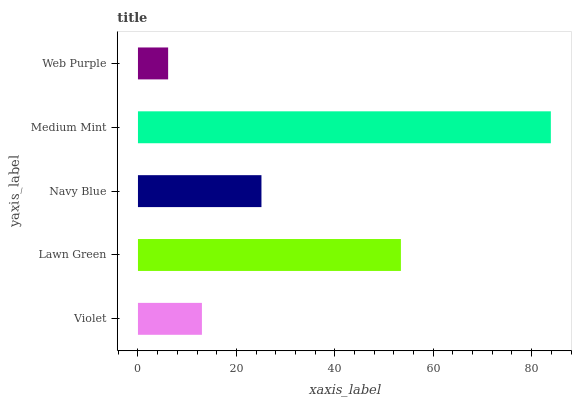Is Web Purple the minimum?
Answer yes or no. Yes. Is Medium Mint the maximum?
Answer yes or no. Yes. Is Lawn Green the minimum?
Answer yes or no. No. Is Lawn Green the maximum?
Answer yes or no. No. Is Lawn Green greater than Violet?
Answer yes or no. Yes. Is Violet less than Lawn Green?
Answer yes or no. Yes. Is Violet greater than Lawn Green?
Answer yes or no. No. Is Lawn Green less than Violet?
Answer yes or no. No. Is Navy Blue the high median?
Answer yes or no. Yes. Is Navy Blue the low median?
Answer yes or no. Yes. Is Lawn Green the high median?
Answer yes or no. No. Is Lawn Green the low median?
Answer yes or no. No. 